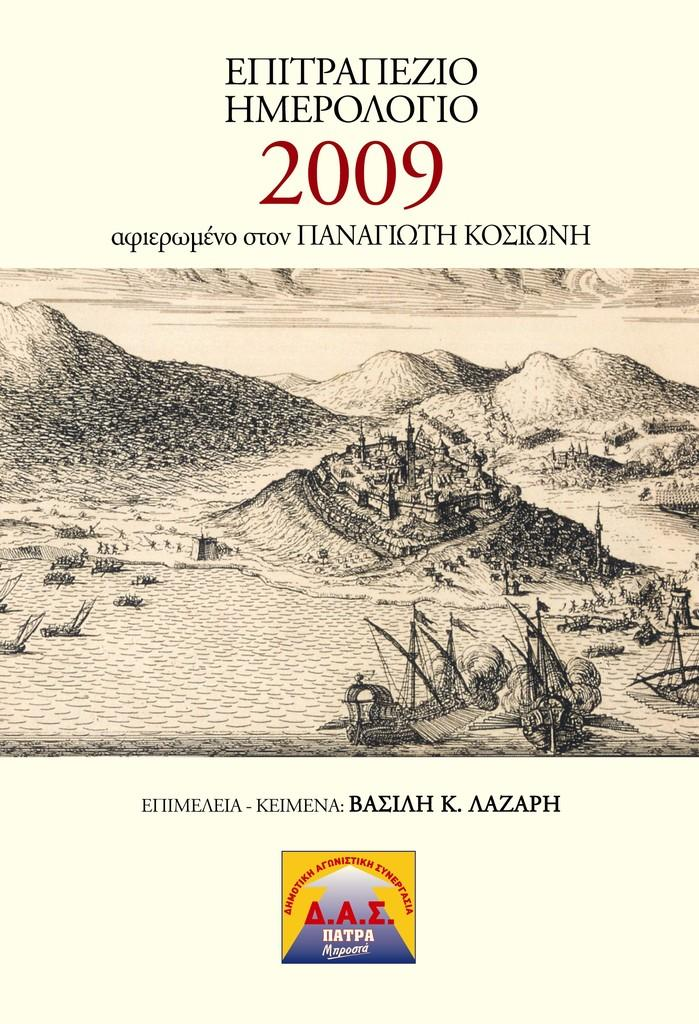Provide a one-sentence caption for the provided image. mountains and landscape with a castle taken in 2009. 